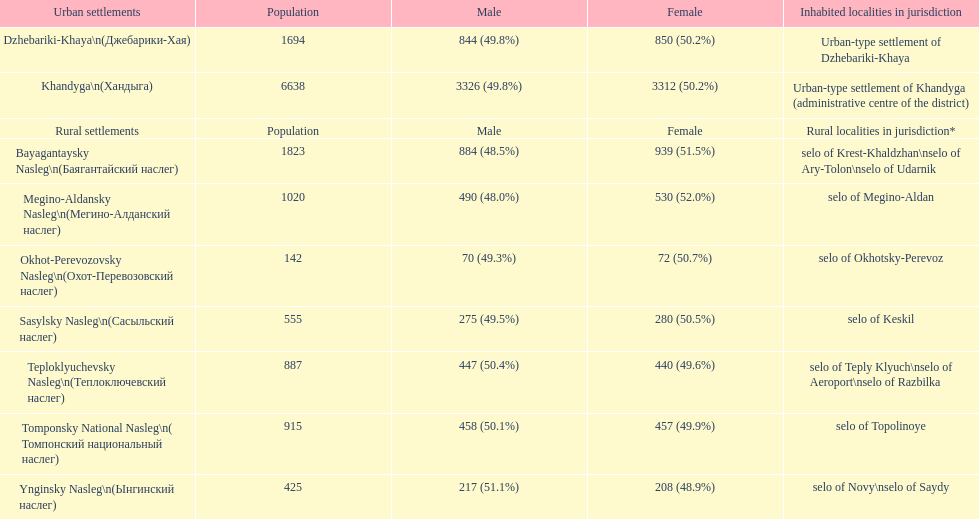What is the overall population in dzhebariki-khaya? 1694. 